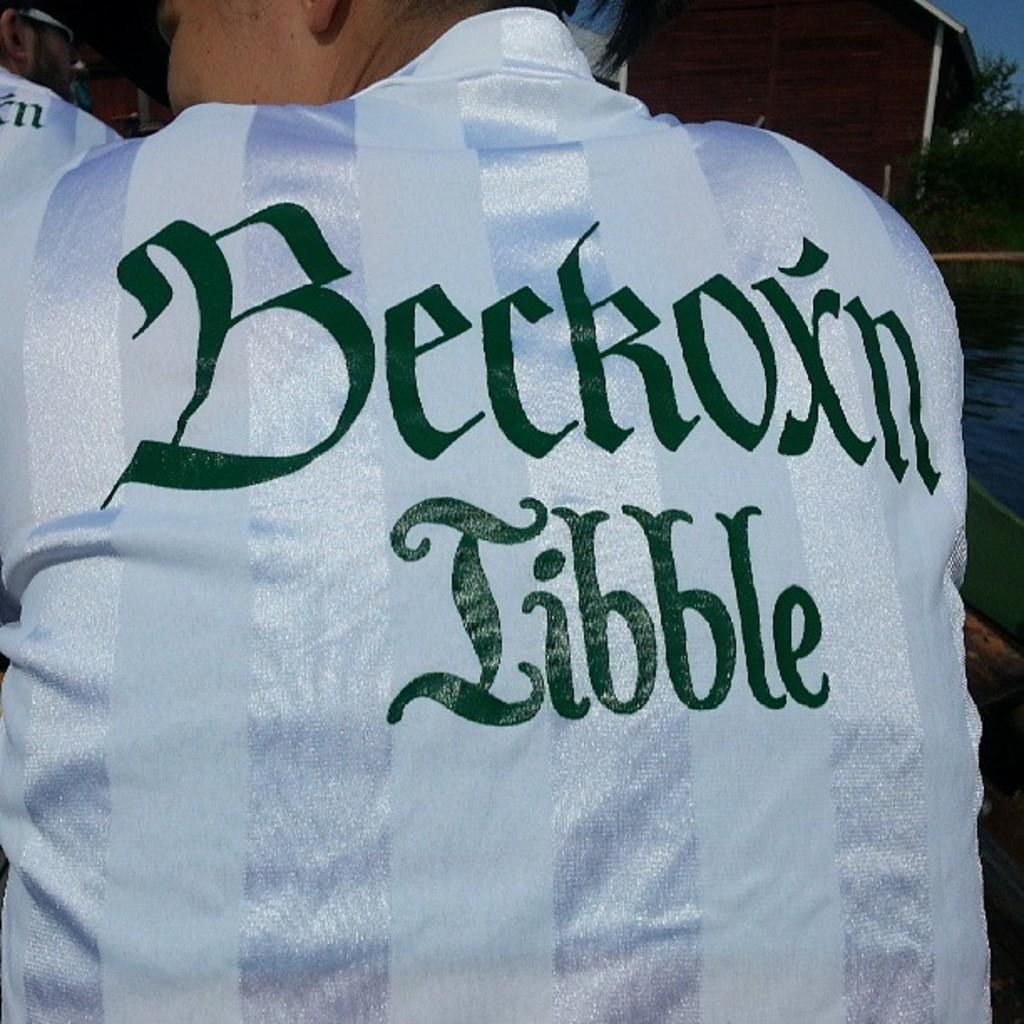<image>
Create a compact narrative representing the image presented. A man's jacket sports the phrase Beckoxn Tibble on the back of it. 